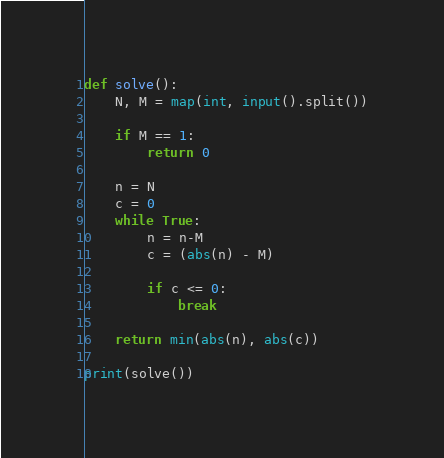Convert code to text. <code><loc_0><loc_0><loc_500><loc_500><_Python_>def solve():
    N, M = map(int, input().split())
    
    if M == 1:
        return 0
    
    n = N
    c = 0
    while True:
        n = n-M
        c = (abs(n) - M)
        
        if c <= 0:
            break

    return min(abs(n), abs(c))

print(solve())</code> 